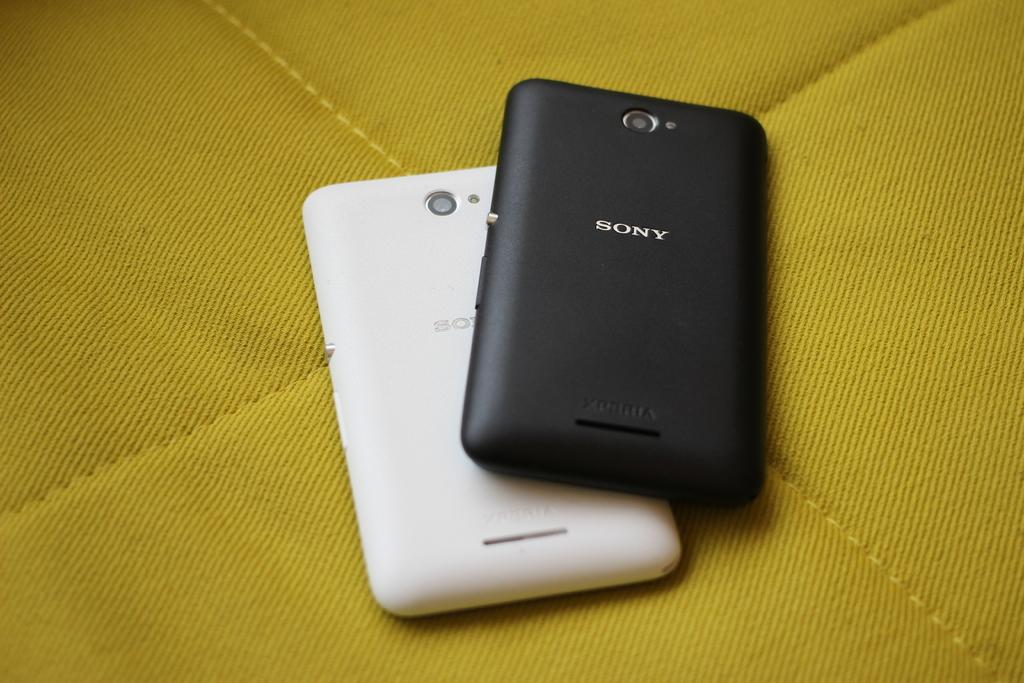<image>
Render a clear and concise summary of the photo. A black Sony cell phone face down and partially covering a white cell phone. 